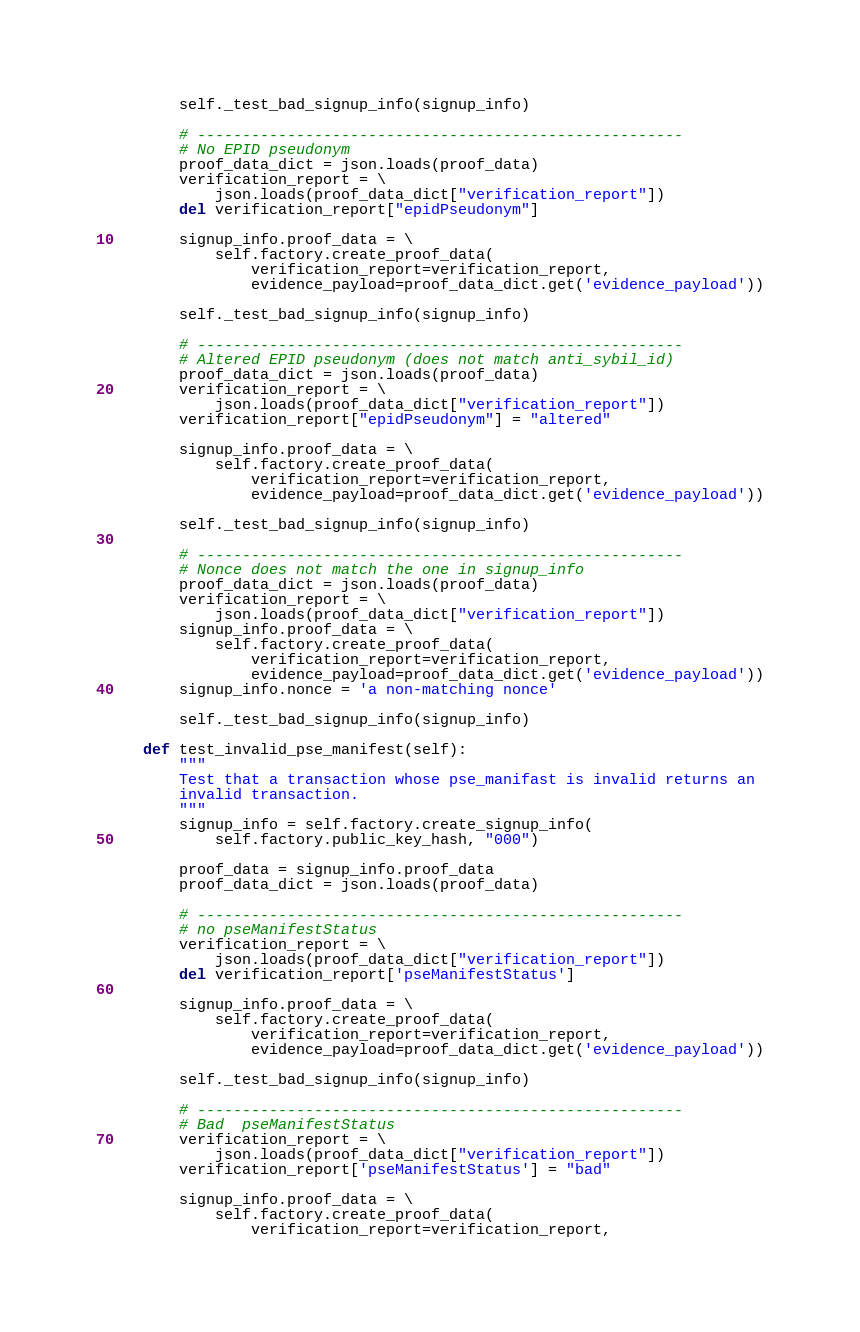<code> <loc_0><loc_0><loc_500><loc_500><_Python_>        self._test_bad_signup_info(signup_info)

        # ------------------------------------------------------
        # No EPID pseudonym
        proof_data_dict = json.loads(proof_data)
        verification_report = \
            json.loads(proof_data_dict["verification_report"])
        del verification_report["epidPseudonym"]

        signup_info.proof_data = \
            self.factory.create_proof_data(
                verification_report=verification_report,
                evidence_payload=proof_data_dict.get('evidence_payload'))

        self._test_bad_signup_info(signup_info)

        # ------------------------------------------------------
        # Altered EPID pseudonym (does not match anti_sybil_id)
        proof_data_dict = json.loads(proof_data)
        verification_report = \
            json.loads(proof_data_dict["verification_report"])
        verification_report["epidPseudonym"] = "altered"

        signup_info.proof_data = \
            self.factory.create_proof_data(
                verification_report=verification_report,
                evidence_payload=proof_data_dict.get('evidence_payload'))

        self._test_bad_signup_info(signup_info)

        # ------------------------------------------------------
        # Nonce does not match the one in signup_info
        proof_data_dict = json.loads(proof_data)
        verification_report = \
            json.loads(proof_data_dict["verification_report"])
        signup_info.proof_data = \
            self.factory.create_proof_data(
                verification_report=verification_report,
                evidence_payload=proof_data_dict.get('evidence_payload'))
        signup_info.nonce = 'a non-matching nonce'

        self._test_bad_signup_info(signup_info)

    def test_invalid_pse_manifest(self):
        """
        Test that a transaction whose pse_manifast is invalid returns an
        invalid transaction.
        """
        signup_info = self.factory.create_signup_info(
            self.factory.public_key_hash, "000")

        proof_data = signup_info.proof_data
        proof_data_dict = json.loads(proof_data)

        # ------------------------------------------------------
        # no pseManifestStatus
        verification_report = \
            json.loads(proof_data_dict["verification_report"])
        del verification_report['pseManifestStatus']

        signup_info.proof_data = \
            self.factory.create_proof_data(
                verification_report=verification_report,
                evidence_payload=proof_data_dict.get('evidence_payload'))

        self._test_bad_signup_info(signup_info)

        # ------------------------------------------------------
        # Bad  pseManifestStatus
        verification_report = \
            json.loads(proof_data_dict["verification_report"])
        verification_report['pseManifestStatus'] = "bad"

        signup_info.proof_data = \
            self.factory.create_proof_data(
                verification_report=verification_report,</code> 